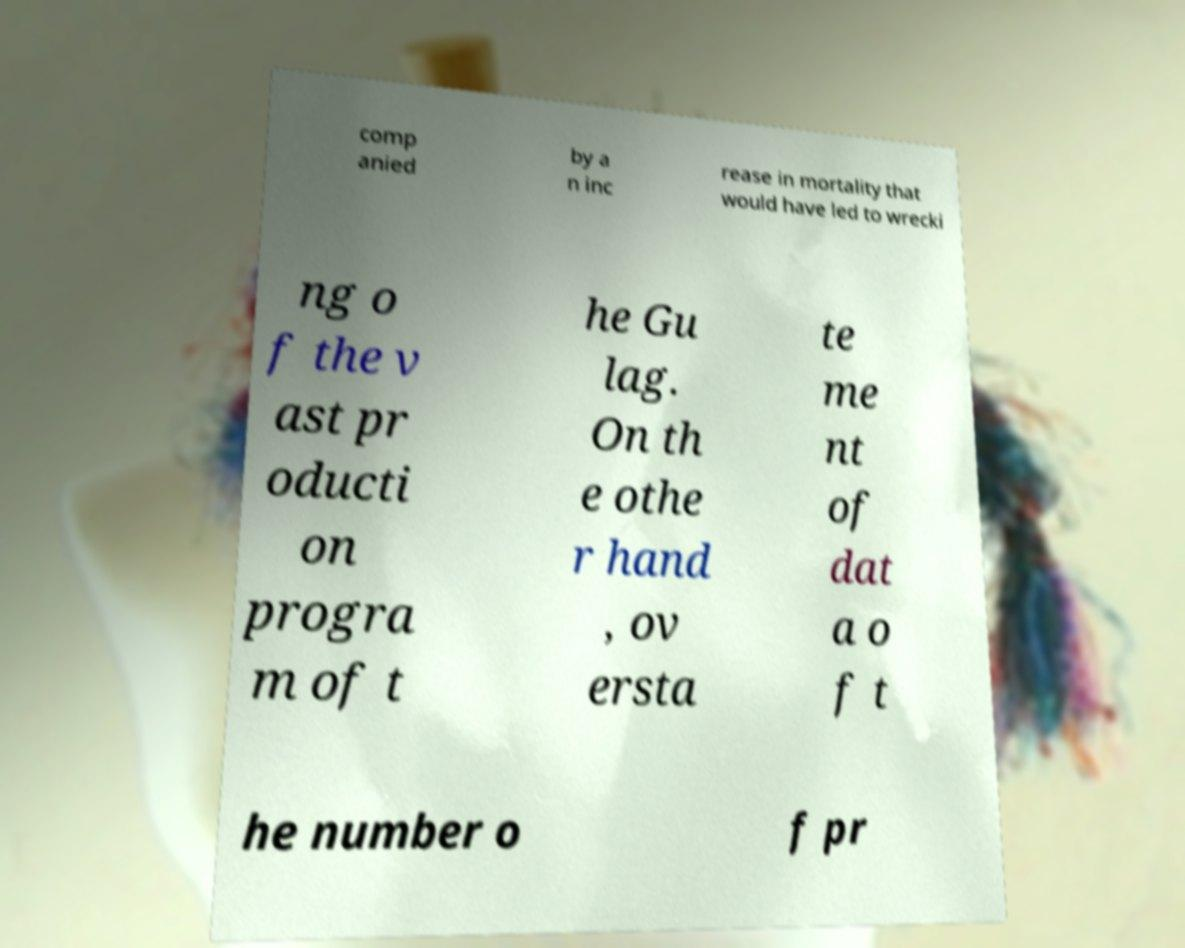Can you read and provide the text displayed in the image?This photo seems to have some interesting text. Can you extract and type it out for me? comp anied by a n inc rease in mortality that would have led to wrecki ng o f the v ast pr oducti on progra m of t he Gu lag. On th e othe r hand , ov ersta te me nt of dat a o f t he number o f pr 